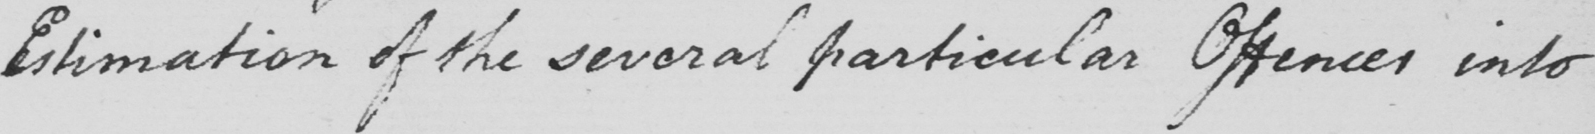Can you read and transcribe this handwriting? Estimation of the several particular Offences into 